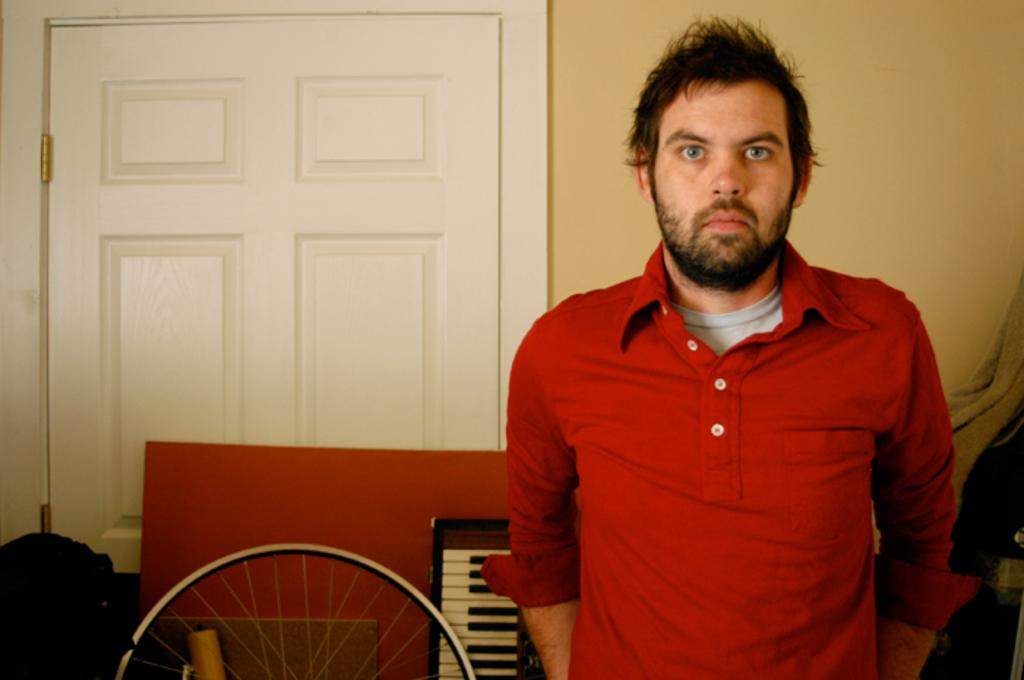Who is present in the image? There is a man in the image. What is the man wearing? The man is wearing a red T-shirt. What can be seen in the background of the image? There is a door, a bag, a wheel, a piano, and a wall in the background of the image. What is the rate of the trains passing by in the image? There are no trains present in the image, so it is not possible to determine the rate at which they might pass by. 